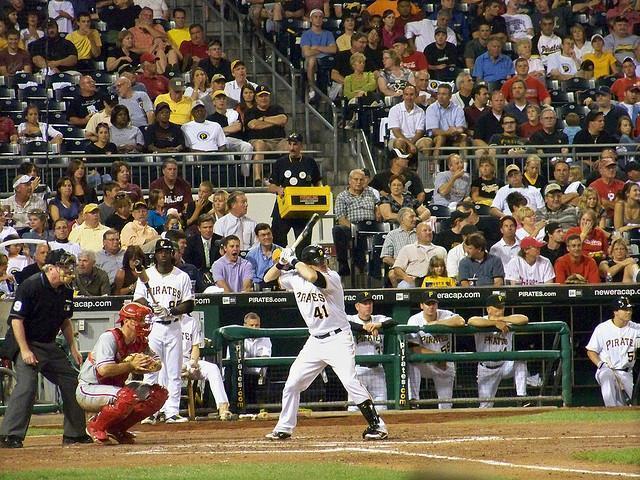What number is the batter wearing?
Choose the right answer and clarify with the format: 'Answer: answer
Rationale: rationale.'
Options: 41, 99, 77, 83. Answer: 41.
Rationale: The batter has the number 41 on the front of his shirt. 